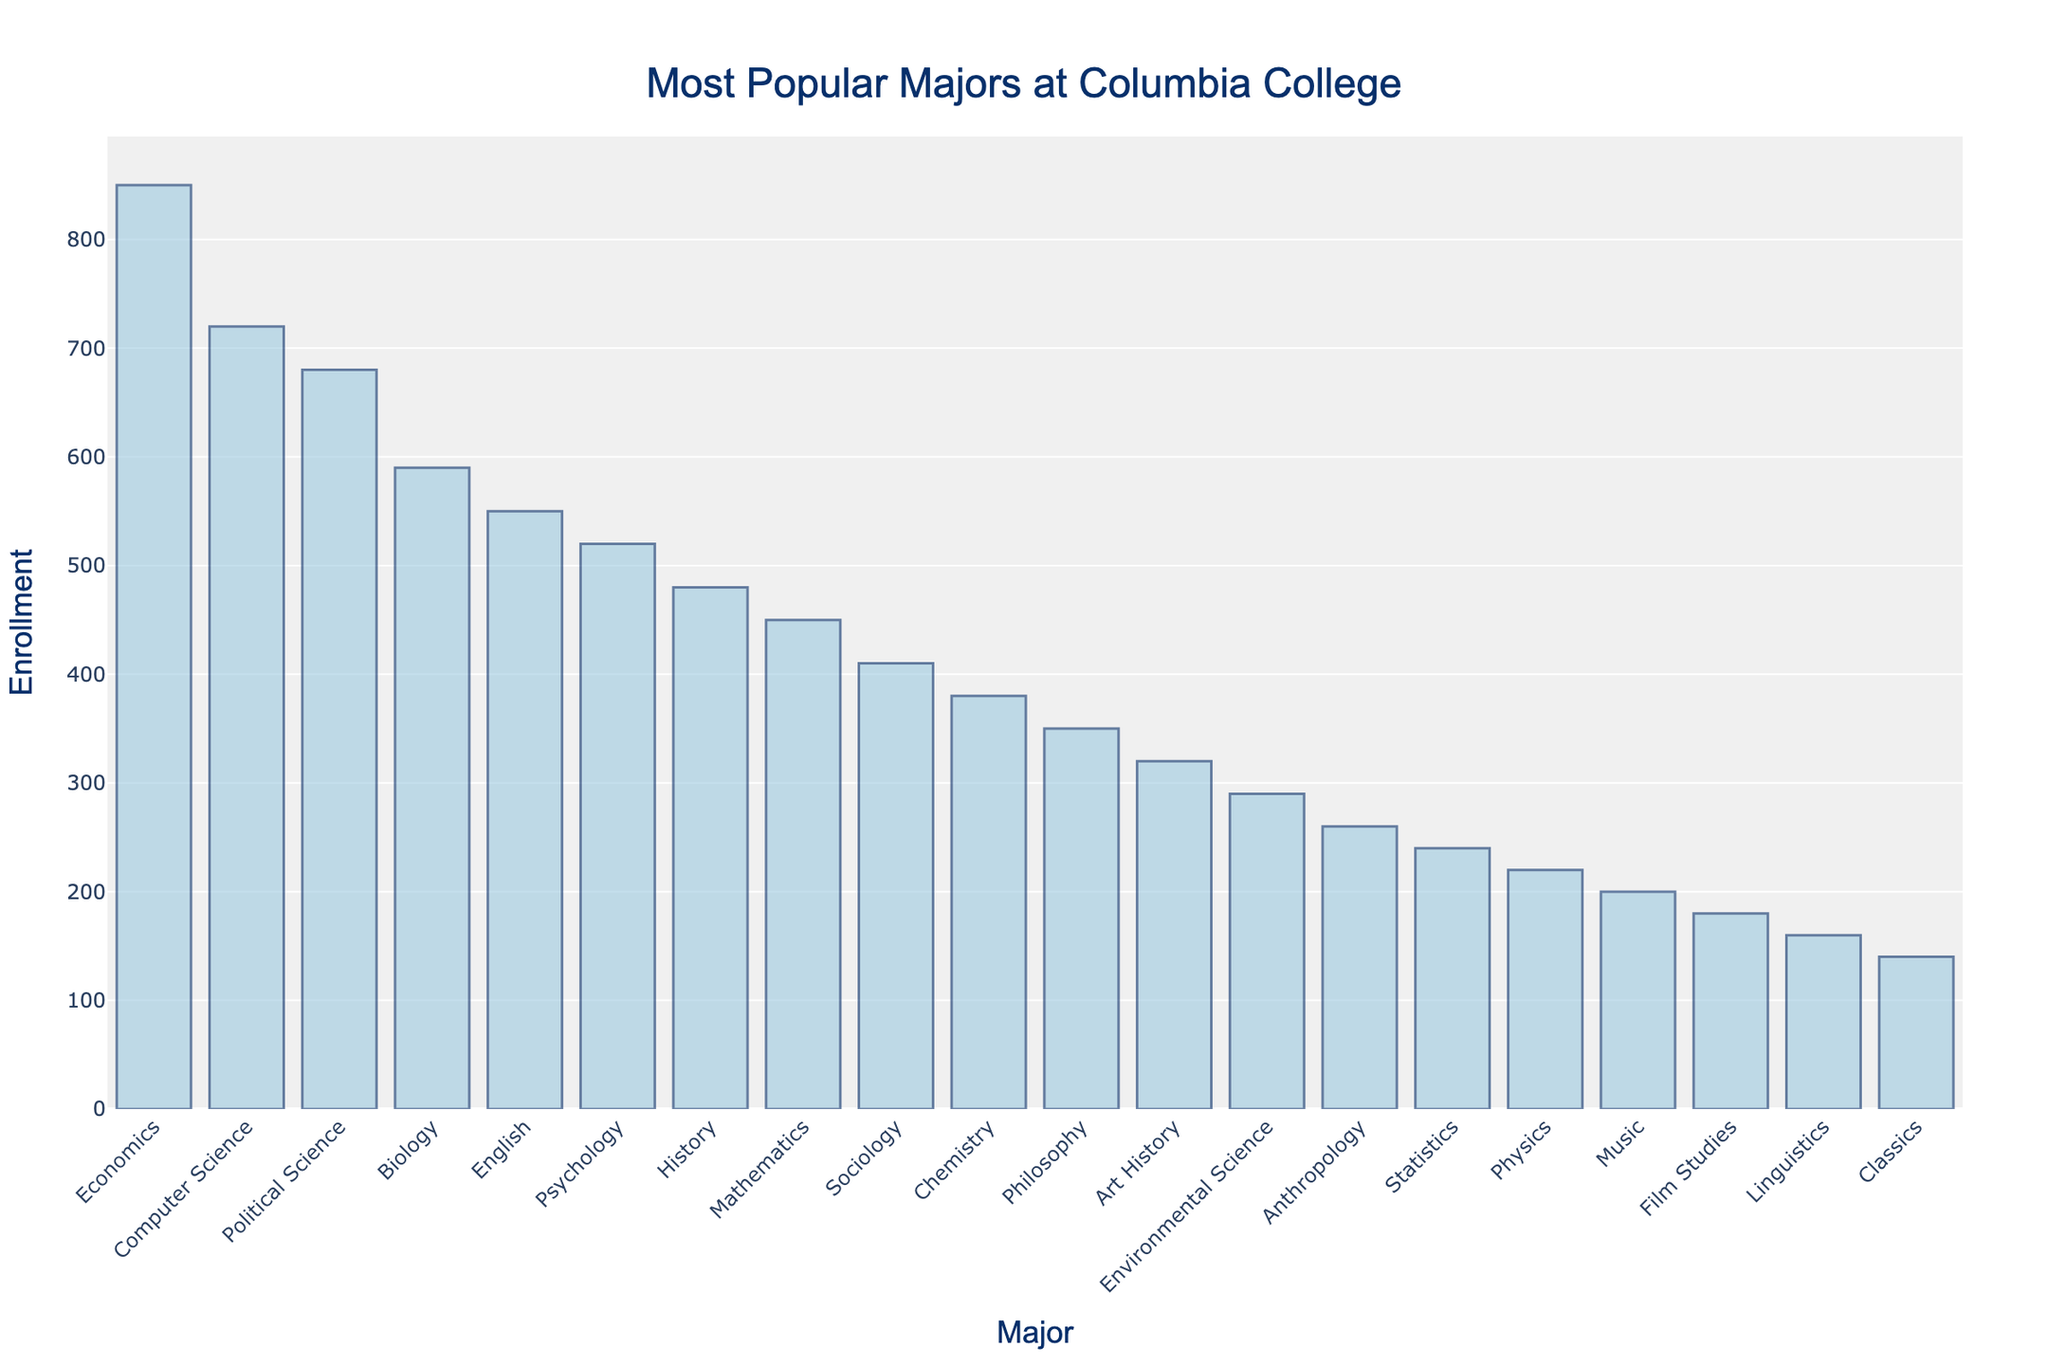What is the most popular major at Columbia College? The bar chart shows the number of students enrolled in different majors. The tallest bar represents the major with the highest enrollment. The bar for Economics is the tallest.
Answer: Economics Which majors have more than 600 students enrolled? To determine which majors have enrollments above 600, look for bars that extend above the 600 mark on the y-axis. Economics, Computer Science, and Political Science have enrollments above 600 students.
Answer: Economics, Computer Science, Political Science What is the total number of students enrolled in the top three most popular majors? Add the enrollments of the top three majors, which are Economics, Computer Science, and Political Science. The values are 850, 720, and 680 respectively. The sum is 850 + 720 + 680.
Answer: 2250 Which major has an enrollment closest to 500 students? Look for the bar whose top is closest to the 500 mark on the y-axis. Psychology has 520 enrollments, which is closest to 500.
Answer: Psychology How many students are studying Sociology and Chemistry combined? Add the enrollments of Sociology and Chemistry. The values are 410 for Sociology and 380 for Chemistry. The sum is 410 + 380.
Answer: 790 Is the enrollment for Mathematics higher than for History? Compare the lengths of the bars for Mathematics and History. The Mathematics bar represents 450 enrollments, while the History bar represents 480 enrollments.
Answer: No What is the enrollment difference between the most and least popular majors? Subtract the enrollment of the least popular major (Classics with 140 enrollments) from the enrollment of the most popular major (Economics with 850 enrollments). The difference is 850 - 140.
Answer: 710 Which has a higher enrollment, Film Studies or Music? Compare the bars for Film Studies and Music. Film Studies has 180 enrollments, while Music has 200 enrollments.
Answer: Music What is the median enrollment among these majors? Sort the enrollment values and find the middle value. The sorted enrollments are 140, 160, 180, 200, 220, 240, 260, 290, 320, 350, 380, 410, 450, 480, 520, 550, 590, 680, 720, 850. The median is the average of the 10th and 11th values (350 and 380), so (350 + 380) / 2.
Answer: 365 